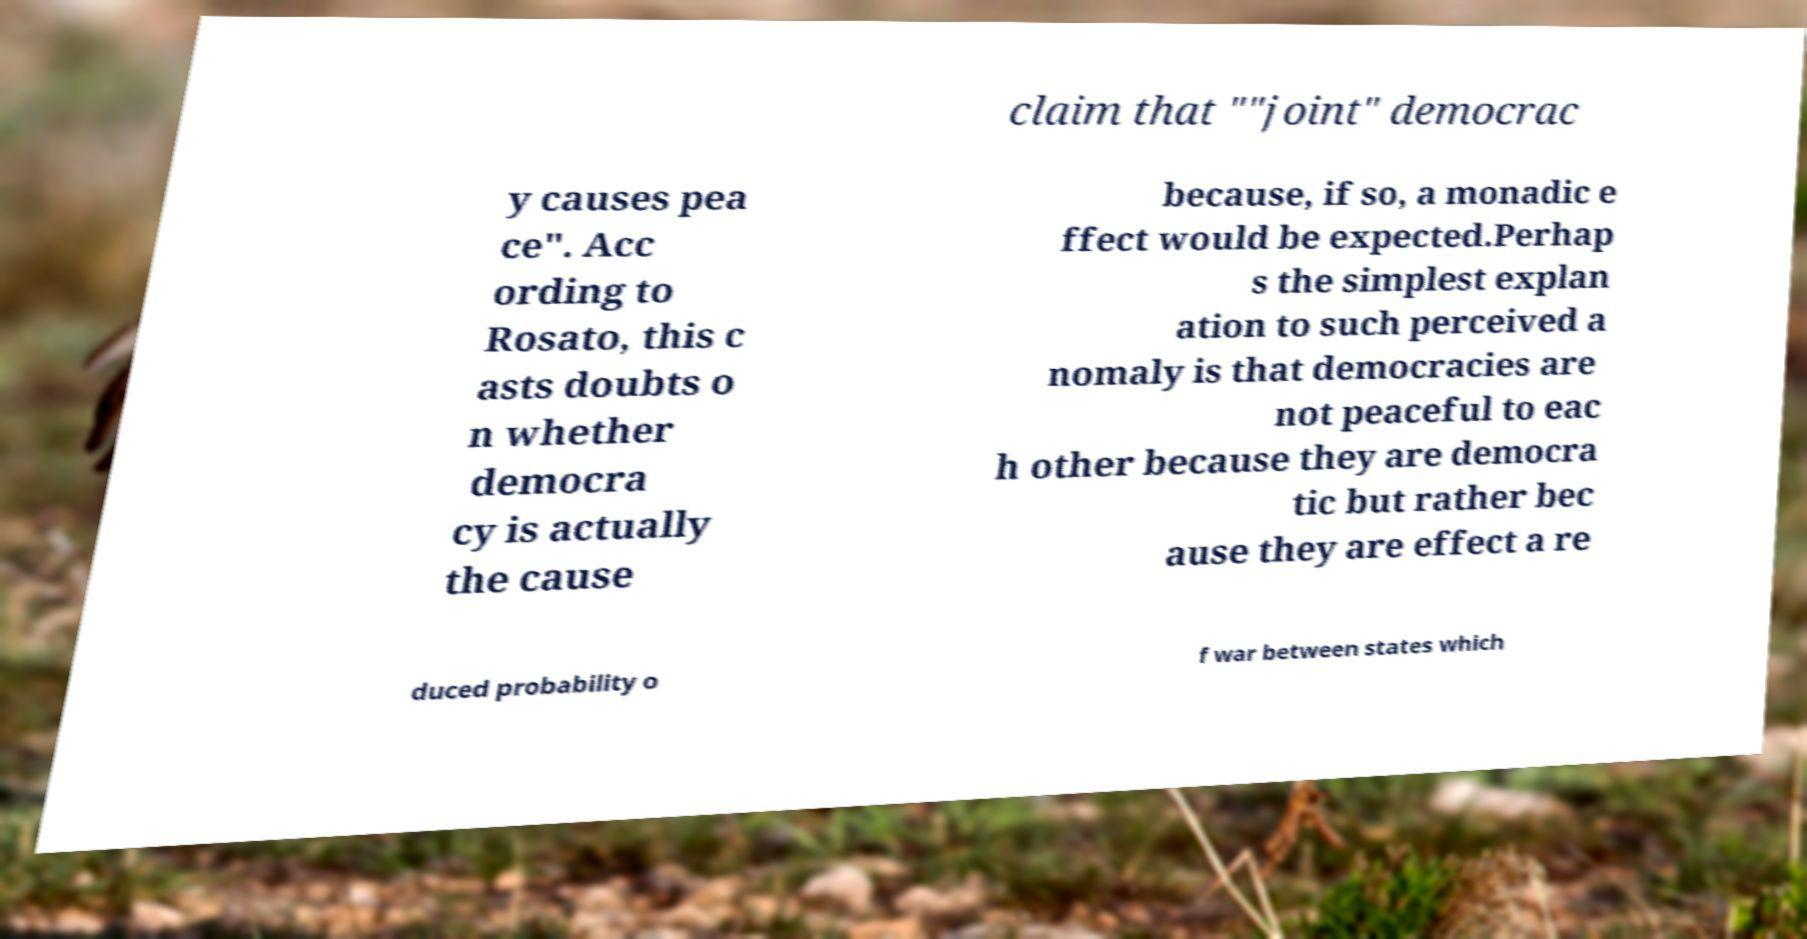Can you read and provide the text displayed in the image?This photo seems to have some interesting text. Can you extract and type it out for me? claim that ""joint" democrac y causes pea ce". Acc ording to Rosato, this c asts doubts o n whether democra cy is actually the cause because, if so, a monadic e ffect would be expected.Perhap s the simplest explan ation to such perceived a nomaly is that democracies are not peaceful to eac h other because they are democra tic but rather bec ause they are effect a re duced probability o f war between states which 